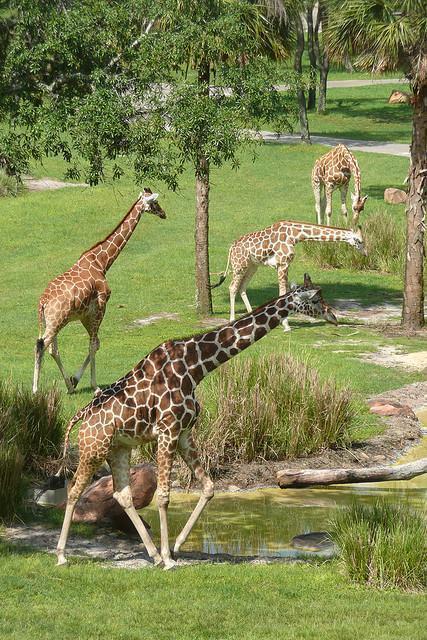What does the animal in the foreground have?
From the following four choices, select the correct answer to address the question.
Options: Wings, gills, spots, quills. Spots. 